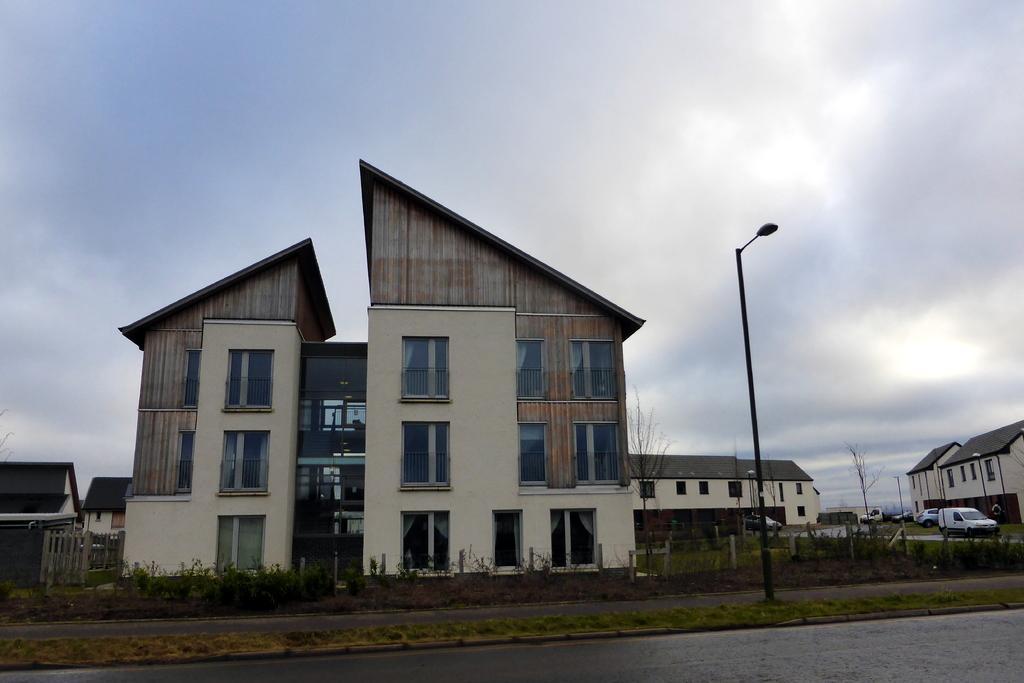Could you give a brief overview of what you see in this image? In the foreground of this picture, there is a road, grass and pole. In the background, there are buildings, cars, trees and the cloud. 